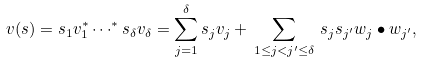<formula> <loc_0><loc_0><loc_500><loc_500>v ( s ) = s _ { 1 } v _ { 1 } ^ { * } \cdots ^ { * } s _ { \delta } v _ { \delta } = \sum _ { j = 1 } ^ { \delta } s _ { j } v _ { j } + \, \sum _ { 1 \leq j < j ^ { \prime } \leq \delta } \, s _ { j } s _ { j ^ { \prime } } w _ { j } \bullet w _ { j ^ { \prime } } ,</formula> 